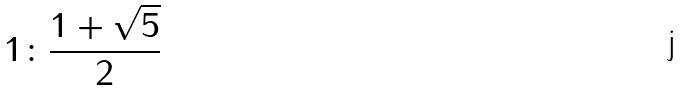Convert formula to latex. <formula><loc_0><loc_0><loc_500><loc_500>1 \colon \frac { 1 + \sqrt { 5 } } { 2 }</formula> 